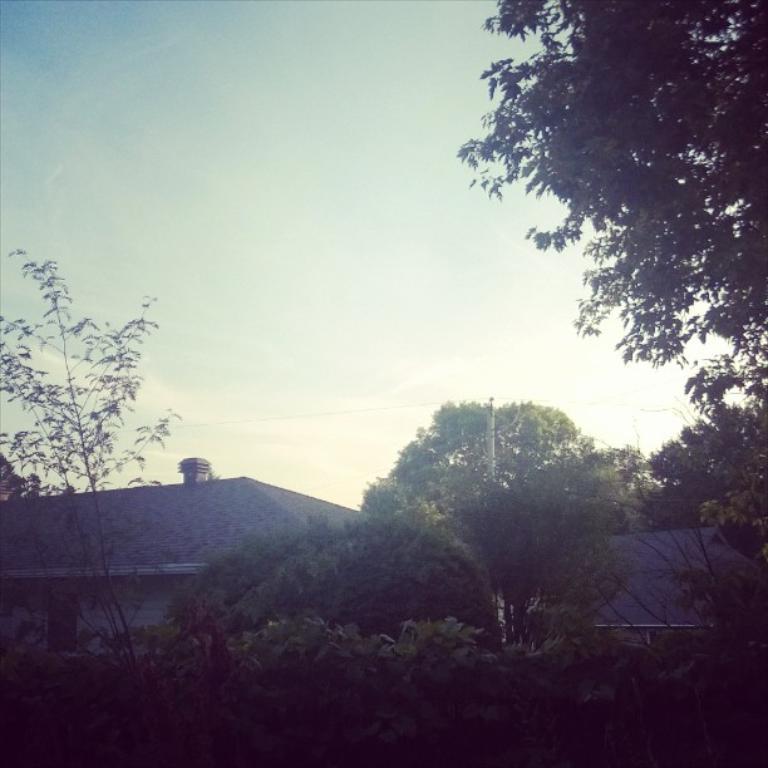Could you give a brief overview of what you see in this image? In this picture I can see trees. I can see the roofs of the houses. I can see clouds in the sky. 